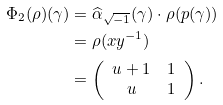<formula> <loc_0><loc_0><loc_500><loc_500>\Phi _ { 2 } ( \rho ) ( \gamma ) & = \widehat { \alpha } _ { \sqrt { - 1 } } ( \gamma ) \cdot \rho ( p ( \gamma ) ) \\ & = \rho ( x y ^ { - 1 } ) \\ & = \left ( \begin{array} { c c } u + 1 & 1 \\ u & 1 \end{array} \right ) .</formula> 